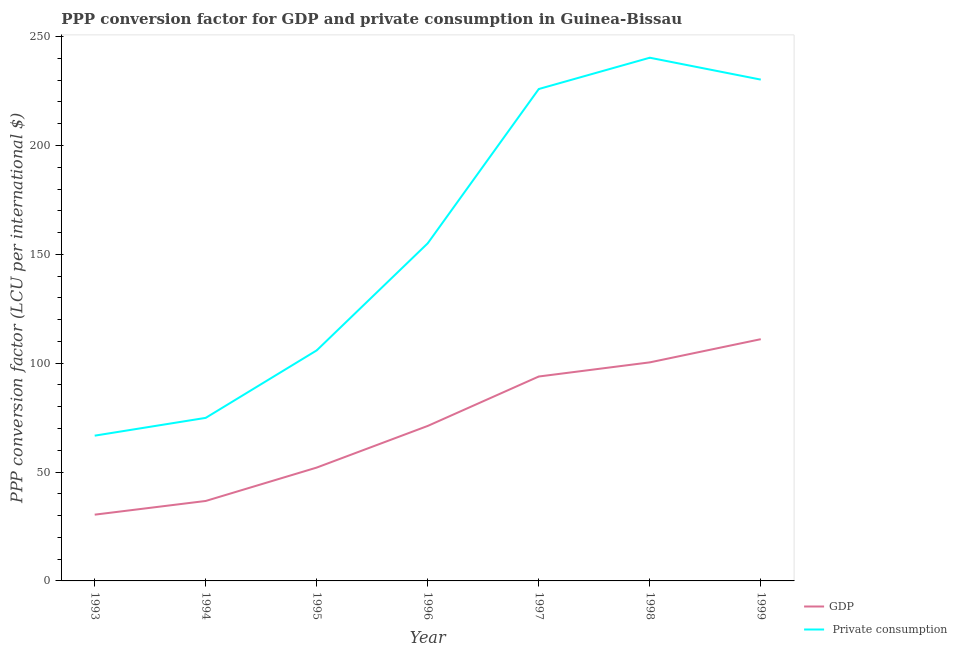How many different coloured lines are there?
Provide a short and direct response. 2. What is the ppp conversion factor for private consumption in 1999?
Keep it short and to the point. 230.26. Across all years, what is the maximum ppp conversion factor for private consumption?
Offer a terse response. 240.31. Across all years, what is the minimum ppp conversion factor for private consumption?
Provide a short and direct response. 66.72. In which year was the ppp conversion factor for gdp maximum?
Keep it short and to the point. 1999. What is the total ppp conversion factor for gdp in the graph?
Offer a terse response. 495.72. What is the difference between the ppp conversion factor for gdp in 1993 and that in 1999?
Your answer should be very brief. -80.6. What is the difference between the ppp conversion factor for private consumption in 1996 and the ppp conversion factor for gdp in 1995?
Your answer should be compact. 103.01. What is the average ppp conversion factor for gdp per year?
Keep it short and to the point. 70.82. In the year 1996, what is the difference between the ppp conversion factor for gdp and ppp conversion factor for private consumption?
Your response must be concise. -83.88. In how many years, is the ppp conversion factor for gdp greater than 170 LCU?
Give a very brief answer. 0. What is the ratio of the ppp conversion factor for gdp in 1993 to that in 1998?
Your answer should be very brief. 0.3. Is the difference between the ppp conversion factor for private consumption in 1998 and 1999 greater than the difference between the ppp conversion factor for gdp in 1998 and 1999?
Provide a succinct answer. Yes. What is the difference between the highest and the second highest ppp conversion factor for gdp?
Your response must be concise. 10.65. What is the difference between the highest and the lowest ppp conversion factor for gdp?
Offer a terse response. 80.6. In how many years, is the ppp conversion factor for private consumption greater than the average ppp conversion factor for private consumption taken over all years?
Ensure brevity in your answer.  3. Does the ppp conversion factor for private consumption monotonically increase over the years?
Give a very brief answer. No. Is the ppp conversion factor for gdp strictly greater than the ppp conversion factor for private consumption over the years?
Your response must be concise. No. How many years are there in the graph?
Provide a short and direct response. 7. Are the values on the major ticks of Y-axis written in scientific E-notation?
Offer a terse response. No. Does the graph contain grids?
Your answer should be compact. No. What is the title of the graph?
Provide a short and direct response. PPP conversion factor for GDP and private consumption in Guinea-Bissau. What is the label or title of the Y-axis?
Offer a terse response. PPP conversion factor (LCU per international $). What is the PPP conversion factor (LCU per international $) in GDP in 1993?
Offer a terse response. 30.43. What is the PPP conversion factor (LCU per international $) in  Private consumption in 1993?
Offer a very short reply. 66.72. What is the PPP conversion factor (LCU per international $) in GDP in 1994?
Your answer should be very brief. 36.72. What is the PPP conversion factor (LCU per international $) of  Private consumption in 1994?
Give a very brief answer. 74.89. What is the PPP conversion factor (LCU per international $) in GDP in 1995?
Offer a very short reply. 52.07. What is the PPP conversion factor (LCU per international $) in  Private consumption in 1995?
Make the answer very short. 105.9. What is the PPP conversion factor (LCU per international $) in GDP in 1996?
Your response must be concise. 71.19. What is the PPP conversion factor (LCU per international $) in  Private consumption in 1996?
Provide a short and direct response. 155.07. What is the PPP conversion factor (LCU per international $) in GDP in 1997?
Your answer should be very brief. 93.89. What is the PPP conversion factor (LCU per international $) in  Private consumption in 1997?
Your answer should be very brief. 225.94. What is the PPP conversion factor (LCU per international $) of GDP in 1998?
Your response must be concise. 100.38. What is the PPP conversion factor (LCU per international $) of  Private consumption in 1998?
Offer a very short reply. 240.31. What is the PPP conversion factor (LCU per international $) in GDP in 1999?
Make the answer very short. 111.04. What is the PPP conversion factor (LCU per international $) in  Private consumption in 1999?
Ensure brevity in your answer.  230.26. Across all years, what is the maximum PPP conversion factor (LCU per international $) of GDP?
Your response must be concise. 111.04. Across all years, what is the maximum PPP conversion factor (LCU per international $) in  Private consumption?
Make the answer very short. 240.31. Across all years, what is the minimum PPP conversion factor (LCU per international $) in GDP?
Ensure brevity in your answer.  30.43. Across all years, what is the minimum PPP conversion factor (LCU per international $) in  Private consumption?
Keep it short and to the point. 66.72. What is the total PPP conversion factor (LCU per international $) of GDP in the graph?
Offer a very short reply. 495.72. What is the total PPP conversion factor (LCU per international $) of  Private consumption in the graph?
Your answer should be compact. 1099.09. What is the difference between the PPP conversion factor (LCU per international $) of GDP in 1993 and that in 1994?
Provide a short and direct response. -6.29. What is the difference between the PPP conversion factor (LCU per international $) in  Private consumption in 1993 and that in 1994?
Ensure brevity in your answer.  -8.17. What is the difference between the PPP conversion factor (LCU per international $) of GDP in 1993 and that in 1995?
Keep it short and to the point. -21.63. What is the difference between the PPP conversion factor (LCU per international $) in  Private consumption in 1993 and that in 1995?
Offer a very short reply. -39.18. What is the difference between the PPP conversion factor (LCU per international $) of GDP in 1993 and that in 1996?
Your answer should be very brief. -40.76. What is the difference between the PPP conversion factor (LCU per international $) of  Private consumption in 1993 and that in 1996?
Offer a very short reply. -88.36. What is the difference between the PPP conversion factor (LCU per international $) of GDP in 1993 and that in 1997?
Ensure brevity in your answer.  -63.46. What is the difference between the PPP conversion factor (LCU per international $) in  Private consumption in 1993 and that in 1997?
Give a very brief answer. -159.22. What is the difference between the PPP conversion factor (LCU per international $) in GDP in 1993 and that in 1998?
Your response must be concise. -69.95. What is the difference between the PPP conversion factor (LCU per international $) of  Private consumption in 1993 and that in 1998?
Give a very brief answer. -173.59. What is the difference between the PPP conversion factor (LCU per international $) in GDP in 1993 and that in 1999?
Your response must be concise. -80.6. What is the difference between the PPP conversion factor (LCU per international $) in  Private consumption in 1993 and that in 1999?
Your answer should be compact. -163.54. What is the difference between the PPP conversion factor (LCU per international $) in GDP in 1994 and that in 1995?
Your answer should be compact. -15.34. What is the difference between the PPP conversion factor (LCU per international $) in  Private consumption in 1994 and that in 1995?
Offer a very short reply. -31. What is the difference between the PPP conversion factor (LCU per international $) in GDP in 1994 and that in 1996?
Give a very brief answer. -34.47. What is the difference between the PPP conversion factor (LCU per international $) of  Private consumption in 1994 and that in 1996?
Offer a terse response. -80.18. What is the difference between the PPP conversion factor (LCU per international $) of GDP in 1994 and that in 1997?
Your answer should be compact. -57.17. What is the difference between the PPP conversion factor (LCU per international $) in  Private consumption in 1994 and that in 1997?
Provide a short and direct response. -151.04. What is the difference between the PPP conversion factor (LCU per international $) in GDP in 1994 and that in 1998?
Your answer should be compact. -63.66. What is the difference between the PPP conversion factor (LCU per international $) of  Private consumption in 1994 and that in 1998?
Your answer should be compact. -165.42. What is the difference between the PPP conversion factor (LCU per international $) in GDP in 1994 and that in 1999?
Ensure brevity in your answer.  -74.31. What is the difference between the PPP conversion factor (LCU per international $) of  Private consumption in 1994 and that in 1999?
Provide a succinct answer. -155.37. What is the difference between the PPP conversion factor (LCU per international $) of GDP in 1995 and that in 1996?
Ensure brevity in your answer.  -19.13. What is the difference between the PPP conversion factor (LCU per international $) of  Private consumption in 1995 and that in 1996?
Your answer should be very brief. -49.18. What is the difference between the PPP conversion factor (LCU per international $) of GDP in 1995 and that in 1997?
Keep it short and to the point. -41.82. What is the difference between the PPP conversion factor (LCU per international $) in  Private consumption in 1995 and that in 1997?
Make the answer very short. -120.04. What is the difference between the PPP conversion factor (LCU per international $) of GDP in 1995 and that in 1998?
Offer a terse response. -48.32. What is the difference between the PPP conversion factor (LCU per international $) of  Private consumption in 1995 and that in 1998?
Keep it short and to the point. -134.42. What is the difference between the PPP conversion factor (LCU per international $) of GDP in 1995 and that in 1999?
Your answer should be compact. -58.97. What is the difference between the PPP conversion factor (LCU per international $) of  Private consumption in 1995 and that in 1999?
Offer a terse response. -124.36. What is the difference between the PPP conversion factor (LCU per international $) in GDP in 1996 and that in 1997?
Ensure brevity in your answer.  -22.7. What is the difference between the PPP conversion factor (LCU per international $) of  Private consumption in 1996 and that in 1997?
Give a very brief answer. -70.86. What is the difference between the PPP conversion factor (LCU per international $) of GDP in 1996 and that in 1998?
Your answer should be very brief. -29.19. What is the difference between the PPP conversion factor (LCU per international $) of  Private consumption in 1996 and that in 1998?
Provide a short and direct response. -85.24. What is the difference between the PPP conversion factor (LCU per international $) of GDP in 1996 and that in 1999?
Give a very brief answer. -39.84. What is the difference between the PPP conversion factor (LCU per international $) of  Private consumption in 1996 and that in 1999?
Provide a succinct answer. -75.19. What is the difference between the PPP conversion factor (LCU per international $) of GDP in 1997 and that in 1998?
Your answer should be very brief. -6.49. What is the difference between the PPP conversion factor (LCU per international $) in  Private consumption in 1997 and that in 1998?
Your answer should be very brief. -14.38. What is the difference between the PPP conversion factor (LCU per international $) of GDP in 1997 and that in 1999?
Make the answer very short. -17.15. What is the difference between the PPP conversion factor (LCU per international $) in  Private consumption in 1997 and that in 1999?
Your answer should be very brief. -4.32. What is the difference between the PPP conversion factor (LCU per international $) of GDP in 1998 and that in 1999?
Offer a very short reply. -10.65. What is the difference between the PPP conversion factor (LCU per international $) of  Private consumption in 1998 and that in 1999?
Offer a very short reply. 10.05. What is the difference between the PPP conversion factor (LCU per international $) in GDP in 1993 and the PPP conversion factor (LCU per international $) in  Private consumption in 1994?
Make the answer very short. -44.46. What is the difference between the PPP conversion factor (LCU per international $) in GDP in 1993 and the PPP conversion factor (LCU per international $) in  Private consumption in 1995?
Offer a terse response. -75.46. What is the difference between the PPP conversion factor (LCU per international $) in GDP in 1993 and the PPP conversion factor (LCU per international $) in  Private consumption in 1996?
Make the answer very short. -124.64. What is the difference between the PPP conversion factor (LCU per international $) in GDP in 1993 and the PPP conversion factor (LCU per international $) in  Private consumption in 1997?
Provide a succinct answer. -195.51. What is the difference between the PPP conversion factor (LCU per international $) in GDP in 1993 and the PPP conversion factor (LCU per international $) in  Private consumption in 1998?
Give a very brief answer. -209.88. What is the difference between the PPP conversion factor (LCU per international $) in GDP in 1993 and the PPP conversion factor (LCU per international $) in  Private consumption in 1999?
Your response must be concise. -199.83. What is the difference between the PPP conversion factor (LCU per international $) of GDP in 1994 and the PPP conversion factor (LCU per international $) of  Private consumption in 1995?
Ensure brevity in your answer.  -69.17. What is the difference between the PPP conversion factor (LCU per international $) in GDP in 1994 and the PPP conversion factor (LCU per international $) in  Private consumption in 1996?
Offer a very short reply. -118.35. What is the difference between the PPP conversion factor (LCU per international $) of GDP in 1994 and the PPP conversion factor (LCU per international $) of  Private consumption in 1997?
Provide a succinct answer. -189.21. What is the difference between the PPP conversion factor (LCU per international $) of GDP in 1994 and the PPP conversion factor (LCU per international $) of  Private consumption in 1998?
Your answer should be very brief. -203.59. What is the difference between the PPP conversion factor (LCU per international $) in GDP in 1994 and the PPP conversion factor (LCU per international $) in  Private consumption in 1999?
Your response must be concise. -193.54. What is the difference between the PPP conversion factor (LCU per international $) of GDP in 1995 and the PPP conversion factor (LCU per international $) of  Private consumption in 1996?
Your answer should be compact. -103.01. What is the difference between the PPP conversion factor (LCU per international $) of GDP in 1995 and the PPP conversion factor (LCU per international $) of  Private consumption in 1997?
Provide a short and direct response. -173.87. What is the difference between the PPP conversion factor (LCU per international $) of GDP in 1995 and the PPP conversion factor (LCU per international $) of  Private consumption in 1998?
Your answer should be very brief. -188.25. What is the difference between the PPP conversion factor (LCU per international $) in GDP in 1995 and the PPP conversion factor (LCU per international $) in  Private consumption in 1999?
Provide a succinct answer. -178.19. What is the difference between the PPP conversion factor (LCU per international $) of GDP in 1996 and the PPP conversion factor (LCU per international $) of  Private consumption in 1997?
Provide a succinct answer. -154.74. What is the difference between the PPP conversion factor (LCU per international $) in GDP in 1996 and the PPP conversion factor (LCU per international $) in  Private consumption in 1998?
Offer a terse response. -169.12. What is the difference between the PPP conversion factor (LCU per international $) of GDP in 1996 and the PPP conversion factor (LCU per international $) of  Private consumption in 1999?
Offer a terse response. -159.07. What is the difference between the PPP conversion factor (LCU per international $) of GDP in 1997 and the PPP conversion factor (LCU per international $) of  Private consumption in 1998?
Ensure brevity in your answer.  -146.42. What is the difference between the PPP conversion factor (LCU per international $) in GDP in 1997 and the PPP conversion factor (LCU per international $) in  Private consumption in 1999?
Your response must be concise. -136.37. What is the difference between the PPP conversion factor (LCU per international $) of GDP in 1998 and the PPP conversion factor (LCU per international $) of  Private consumption in 1999?
Your answer should be compact. -129.88. What is the average PPP conversion factor (LCU per international $) of GDP per year?
Provide a succinct answer. 70.82. What is the average PPP conversion factor (LCU per international $) of  Private consumption per year?
Provide a succinct answer. 157.01. In the year 1993, what is the difference between the PPP conversion factor (LCU per international $) in GDP and PPP conversion factor (LCU per international $) in  Private consumption?
Give a very brief answer. -36.29. In the year 1994, what is the difference between the PPP conversion factor (LCU per international $) in GDP and PPP conversion factor (LCU per international $) in  Private consumption?
Give a very brief answer. -38.17. In the year 1995, what is the difference between the PPP conversion factor (LCU per international $) in GDP and PPP conversion factor (LCU per international $) in  Private consumption?
Make the answer very short. -53.83. In the year 1996, what is the difference between the PPP conversion factor (LCU per international $) of GDP and PPP conversion factor (LCU per international $) of  Private consumption?
Your answer should be compact. -83.88. In the year 1997, what is the difference between the PPP conversion factor (LCU per international $) of GDP and PPP conversion factor (LCU per international $) of  Private consumption?
Ensure brevity in your answer.  -132.05. In the year 1998, what is the difference between the PPP conversion factor (LCU per international $) of GDP and PPP conversion factor (LCU per international $) of  Private consumption?
Your response must be concise. -139.93. In the year 1999, what is the difference between the PPP conversion factor (LCU per international $) in GDP and PPP conversion factor (LCU per international $) in  Private consumption?
Provide a succinct answer. -119.22. What is the ratio of the PPP conversion factor (LCU per international $) in GDP in 1993 to that in 1994?
Give a very brief answer. 0.83. What is the ratio of the PPP conversion factor (LCU per international $) of  Private consumption in 1993 to that in 1994?
Your answer should be compact. 0.89. What is the ratio of the PPP conversion factor (LCU per international $) of GDP in 1993 to that in 1995?
Ensure brevity in your answer.  0.58. What is the ratio of the PPP conversion factor (LCU per international $) in  Private consumption in 1993 to that in 1995?
Your answer should be compact. 0.63. What is the ratio of the PPP conversion factor (LCU per international $) of GDP in 1993 to that in 1996?
Give a very brief answer. 0.43. What is the ratio of the PPP conversion factor (LCU per international $) in  Private consumption in 1993 to that in 1996?
Give a very brief answer. 0.43. What is the ratio of the PPP conversion factor (LCU per international $) of GDP in 1993 to that in 1997?
Give a very brief answer. 0.32. What is the ratio of the PPP conversion factor (LCU per international $) in  Private consumption in 1993 to that in 1997?
Give a very brief answer. 0.3. What is the ratio of the PPP conversion factor (LCU per international $) of GDP in 1993 to that in 1998?
Make the answer very short. 0.3. What is the ratio of the PPP conversion factor (LCU per international $) in  Private consumption in 1993 to that in 1998?
Keep it short and to the point. 0.28. What is the ratio of the PPP conversion factor (LCU per international $) in GDP in 1993 to that in 1999?
Your response must be concise. 0.27. What is the ratio of the PPP conversion factor (LCU per international $) of  Private consumption in 1993 to that in 1999?
Your answer should be compact. 0.29. What is the ratio of the PPP conversion factor (LCU per international $) in GDP in 1994 to that in 1995?
Give a very brief answer. 0.71. What is the ratio of the PPP conversion factor (LCU per international $) of  Private consumption in 1994 to that in 1995?
Ensure brevity in your answer.  0.71. What is the ratio of the PPP conversion factor (LCU per international $) in GDP in 1994 to that in 1996?
Provide a succinct answer. 0.52. What is the ratio of the PPP conversion factor (LCU per international $) of  Private consumption in 1994 to that in 1996?
Ensure brevity in your answer.  0.48. What is the ratio of the PPP conversion factor (LCU per international $) in GDP in 1994 to that in 1997?
Keep it short and to the point. 0.39. What is the ratio of the PPP conversion factor (LCU per international $) of  Private consumption in 1994 to that in 1997?
Ensure brevity in your answer.  0.33. What is the ratio of the PPP conversion factor (LCU per international $) in GDP in 1994 to that in 1998?
Give a very brief answer. 0.37. What is the ratio of the PPP conversion factor (LCU per international $) of  Private consumption in 1994 to that in 1998?
Your answer should be very brief. 0.31. What is the ratio of the PPP conversion factor (LCU per international $) of GDP in 1994 to that in 1999?
Provide a short and direct response. 0.33. What is the ratio of the PPP conversion factor (LCU per international $) of  Private consumption in 1994 to that in 1999?
Keep it short and to the point. 0.33. What is the ratio of the PPP conversion factor (LCU per international $) in GDP in 1995 to that in 1996?
Make the answer very short. 0.73. What is the ratio of the PPP conversion factor (LCU per international $) of  Private consumption in 1995 to that in 1996?
Your response must be concise. 0.68. What is the ratio of the PPP conversion factor (LCU per international $) in GDP in 1995 to that in 1997?
Ensure brevity in your answer.  0.55. What is the ratio of the PPP conversion factor (LCU per international $) in  Private consumption in 1995 to that in 1997?
Your answer should be compact. 0.47. What is the ratio of the PPP conversion factor (LCU per international $) in GDP in 1995 to that in 1998?
Keep it short and to the point. 0.52. What is the ratio of the PPP conversion factor (LCU per international $) in  Private consumption in 1995 to that in 1998?
Make the answer very short. 0.44. What is the ratio of the PPP conversion factor (LCU per international $) in GDP in 1995 to that in 1999?
Give a very brief answer. 0.47. What is the ratio of the PPP conversion factor (LCU per international $) of  Private consumption in 1995 to that in 1999?
Ensure brevity in your answer.  0.46. What is the ratio of the PPP conversion factor (LCU per international $) in GDP in 1996 to that in 1997?
Ensure brevity in your answer.  0.76. What is the ratio of the PPP conversion factor (LCU per international $) of  Private consumption in 1996 to that in 1997?
Ensure brevity in your answer.  0.69. What is the ratio of the PPP conversion factor (LCU per international $) in GDP in 1996 to that in 1998?
Keep it short and to the point. 0.71. What is the ratio of the PPP conversion factor (LCU per international $) of  Private consumption in 1996 to that in 1998?
Provide a short and direct response. 0.65. What is the ratio of the PPP conversion factor (LCU per international $) in GDP in 1996 to that in 1999?
Offer a very short reply. 0.64. What is the ratio of the PPP conversion factor (LCU per international $) in  Private consumption in 1996 to that in 1999?
Your answer should be very brief. 0.67. What is the ratio of the PPP conversion factor (LCU per international $) of GDP in 1997 to that in 1998?
Make the answer very short. 0.94. What is the ratio of the PPP conversion factor (LCU per international $) in  Private consumption in 1997 to that in 1998?
Provide a short and direct response. 0.94. What is the ratio of the PPP conversion factor (LCU per international $) of GDP in 1997 to that in 1999?
Your response must be concise. 0.85. What is the ratio of the PPP conversion factor (LCU per international $) in  Private consumption in 1997 to that in 1999?
Provide a short and direct response. 0.98. What is the ratio of the PPP conversion factor (LCU per international $) of GDP in 1998 to that in 1999?
Keep it short and to the point. 0.9. What is the ratio of the PPP conversion factor (LCU per international $) in  Private consumption in 1998 to that in 1999?
Provide a short and direct response. 1.04. What is the difference between the highest and the second highest PPP conversion factor (LCU per international $) in GDP?
Provide a short and direct response. 10.65. What is the difference between the highest and the second highest PPP conversion factor (LCU per international $) of  Private consumption?
Offer a very short reply. 10.05. What is the difference between the highest and the lowest PPP conversion factor (LCU per international $) of GDP?
Your answer should be very brief. 80.6. What is the difference between the highest and the lowest PPP conversion factor (LCU per international $) of  Private consumption?
Keep it short and to the point. 173.59. 